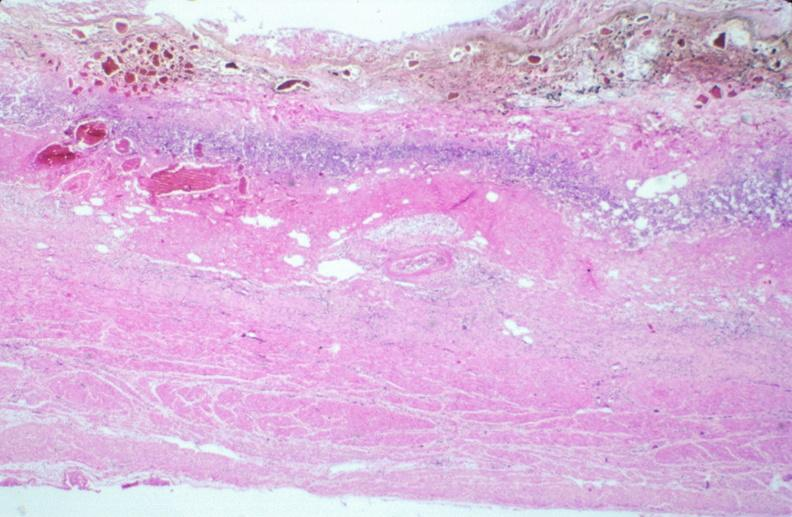s metastatic carcinoma oat cell present?
Answer the question using a single word or phrase. No 